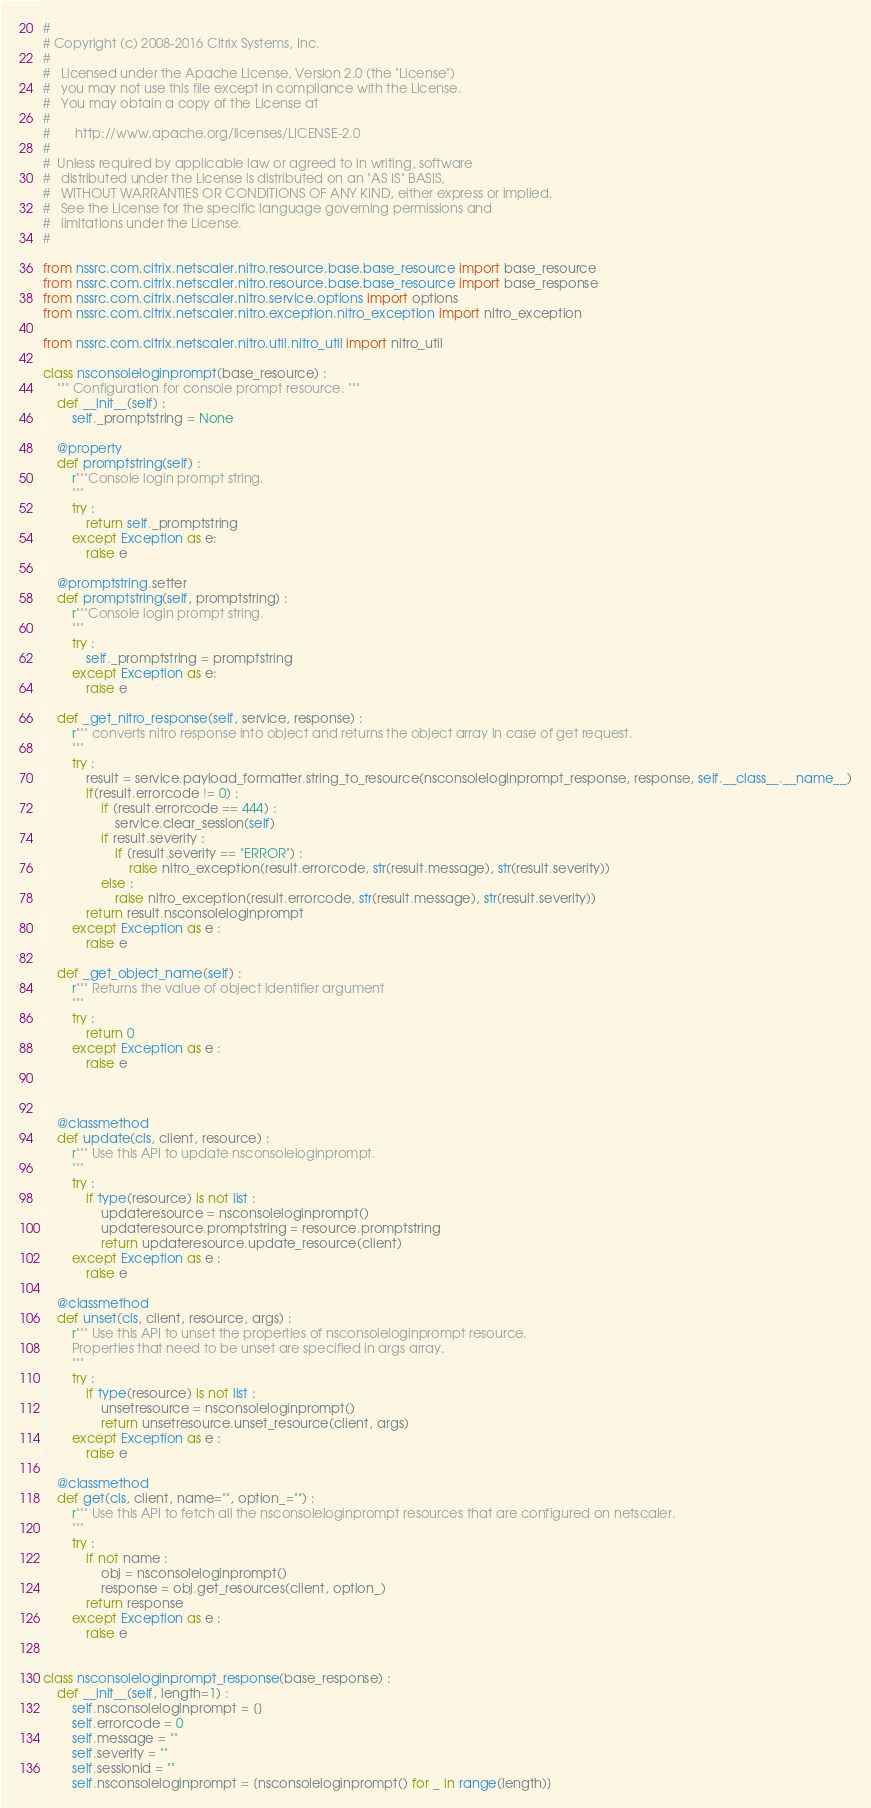Convert code to text. <code><loc_0><loc_0><loc_500><loc_500><_Python_>#
# Copyright (c) 2008-2016 Citrix Systems, Inc.
#
#   Licensed under the Apache License, Version 2.0 (the "License")
#   you may not use this file except in compliance with the License.
#   You may obtain a copy of the License at
#
#       http://www.apache.org/licenses/LICENSE-2.0
#
#  Unless required by applicable law or agreed to in writing, software
#   distributed under the License is distributed on an "AS IS" BASIS,
#   WITHOUT WARRANTIES OR CONDITIONS OF ANY KIND, either express or implied.
#   See the License for the specific language governing permissions and
#   limitations under the License.
#

from nssrc.com.citrix.netscaler.nitro.resource.base.base_resource import base_resource
from nssrc.com.citrix.netscaler.nitro.resource.base.base_resource import base_response
from nssrc.com.citrix.netscaler.nitro.service.options import options
from nssrc.com.citrix.netscaler.nitro.exception.nitro_exception import nitro_exception

from nssrc.com.citrix.netscaler.nitro.util.nitro_util import nitro_util

class nsconsoleloginprompt(base_resource) :
	""" Configuration for console prompt resource. """
	def __init__(self) :
		self._promptstring = None

	@property
	def promptstring(self) :
		r"""Console login prompt string.
		"""
		try :
			return self._promptstring
		except Exception as e:
			raise e

	@promptstring.setter
	def promptstring(self, promptstring) :
		r"""Console login prompt string.
		"""
		try :
			self._promptstring = promptstring
		except Exception as e:
			raise e

	def _get_nitro_response(self, service, response) :
		r""" converts nitro response into object and returns the object array in case of get request.
		"""
		try :
			result = service.payload_formatter.string_to_resource(nsconsoleloginprompt_response, response, self.__class__.__name__)
			if(result.errorcode != 0) :
				if (result.errorcode == 444) :
					service.clear_session(self)
				if result.severity :
					if (result.severity == "ERROR") :
						raise nitro_exception(result.errorcode, str(result.message), str(result.severity))
				else :
					raise nitro_exception(result.errorcode, str(result.message), str(result.severity))
			return result.nsconsoleloginprompt
		except Exception as e :
			raise e

	def _get_object_name(self) :
		r""" Returns the value of object identifier argument
		"""
		try :
			return 0
		except Exception as e :
			raise e



	@classmethod
	def update(cls, client, resource) :
		r""" Use this API to update nsconsoleloginprompt.
		"""
		try :
			if type(resource) is not list :
				updateresource = nsconsoleloginprompt()
				updateresource.promptstring = resource.promptstring
				return updateresource.update_resource(client)
		except Exception as e :
			raise e

	@classmethod
	def unset(cls, client, resource, args) :
		r""" Use this API to unset the properties of nsconsoleloginprompt resource.
		Properties that need to be unset are specified in args array.
		"""
		try :
			if type(resource) is not list :
				unsetresource = nsconsoleloginprompt()
				return unsetresource.unset_resource(client, args)
		except Exception as e :
			raise e

	@classmethod
	def get(cls, client, name="", option_="") :
		r""" Use this API to fetch all the nsconsoleloginprompt resources that are configured on netscaler.
		"""
		try :
			if not name :
				obj = nsconsoleloginprompt()
				response = obj.get_resources(client, option_)
			return response
		except Exception as e :
			raise e


class nsconsoleloginprompt_response(base_response) :
	def __init__(self, length=1) :
		self.nsconsoleloginprompt = []
		self.errorcode = 0
		self.message = ""
		self.severity = ""
		self.sessionid = ""
		self.nsconsoleloginprompt = [nsconsoleloginprompt() for _ in range(length)]

</code> 